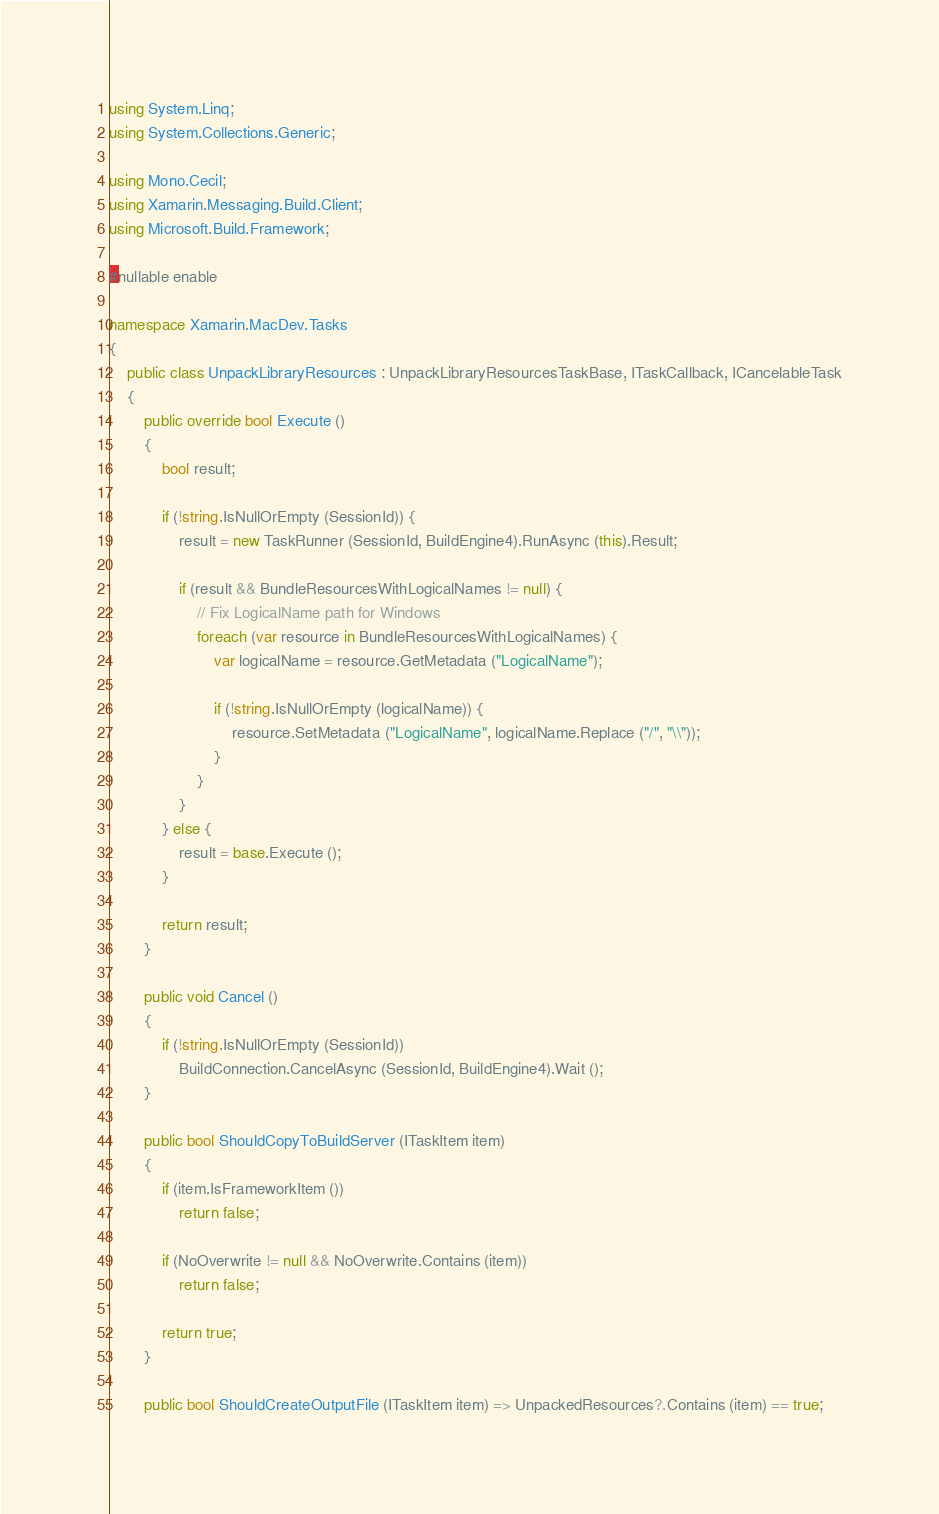<code> <loc_0><loc_0><loc_500><loc_500><_C#_>using System.Linq;
using System.Collections.Generic;

using Mono.Cecil;
using Xamarin.Messaging.Build.Client;
using Microsoft.Build.Framework;

#nullable enable

namespace Xamarin.MacDev.Tasks
{
	public class UnpackLibraryResources : UnpackLibraryResourcesTaskBase, ITaskCallback, ICancelableTask
	{
		public override bool Execute ()
		{
			bool result;

			if (!string.IsNullOrEmpty (SessionId)) {
				result = new TaskRunner (SessionId, BuildEngine4).RunAsync (this).Result;

				if (result && BundleResourcesWithLogicalNames != null) {
					// Fix LogicalName path for Windows
					foreach (var resource in BundleResourcesWithLogicalNames) {
						var logicalName = resource.GetMetadata ("LogicalName");

						if (!string.IsNullOrEmpty (logicalName)) {
							resource.SetMetadata ("LogicalName", logicalName.Replace ("/", "\\"));
						}
					}
				}
			} else {
				result = base.Execute ();
			}	

			return result;
		}

		public void Cancel ()
		{
			if (!string.IsNullOrEmpty (SessionId))
				BuildConnection.CancelAsync (SessionId, BuildEngine4).Wait ();
		}

		public bool ShouldCopyToBuildServer (ITaskItem item)
		{
			if (item.IsFrameworkItem ())
				return false;

			if (NoOverwrite != null && NoOverwrite.Contains (item))
				return false;

			return true;
		}

		public bool ShouldCreateOutputFile (ITaskItem item) => UnpackedResources?.Contains (item) == true;
</code> 